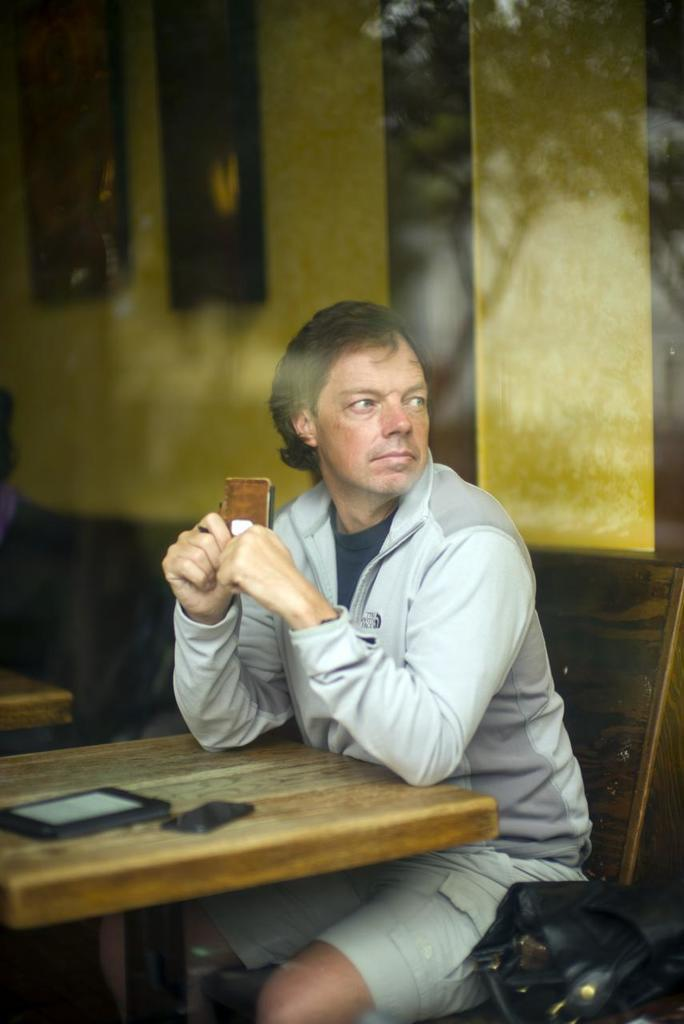Who is present in the image? There is a man in the image. What is the man doing in the image? The man is sitting on a chair. What is in front of the man? There is a table in front of the man. What can be seen on the table? There are two objects on the table. What color are the stockings worn by the man in the image? There is no mention of stockings in the provided facts, and therefore we cannot determine the color of any stockings the man might be wearing. 